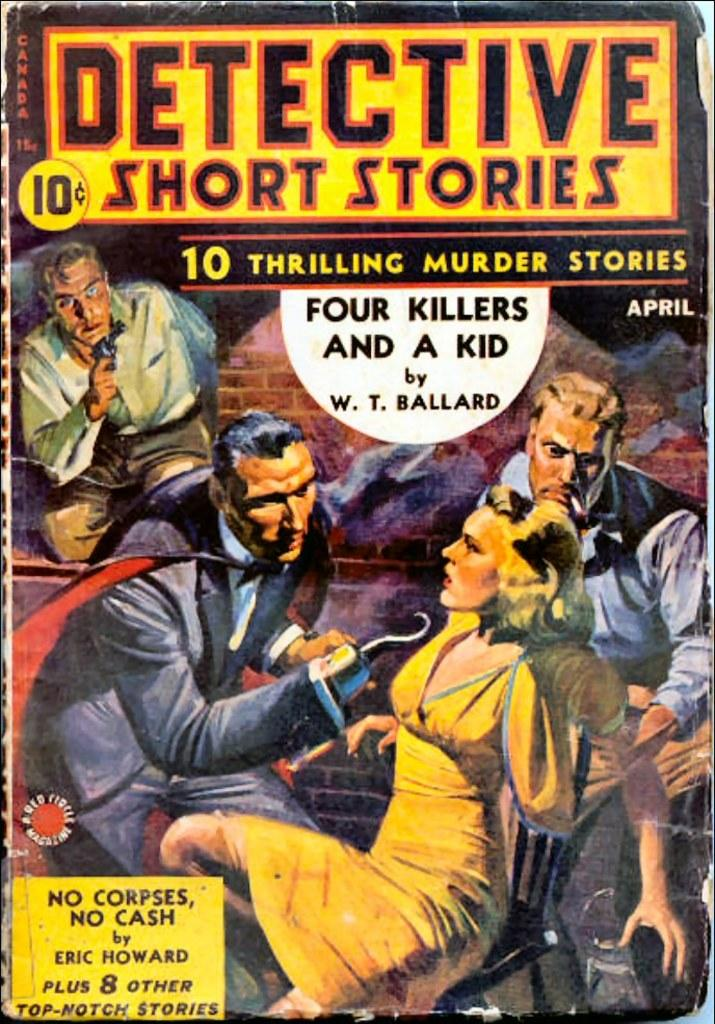Provide a one-sentence caption for the provided image. A colorful short stories paperback book that was original sold for 10 cents. 